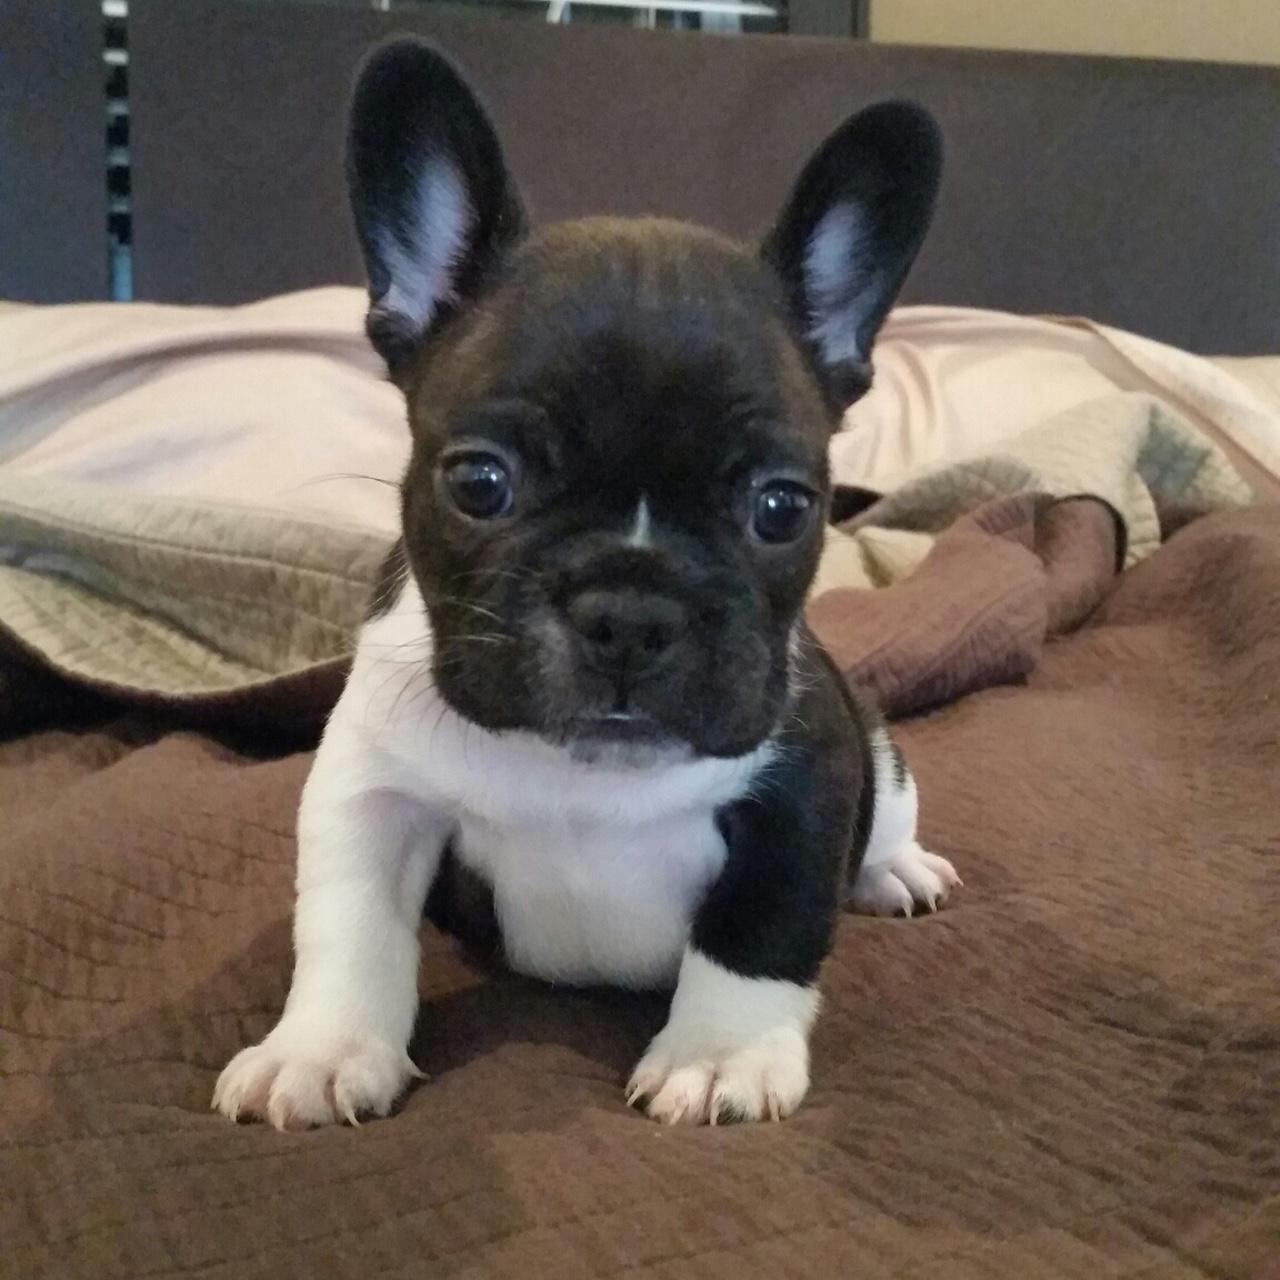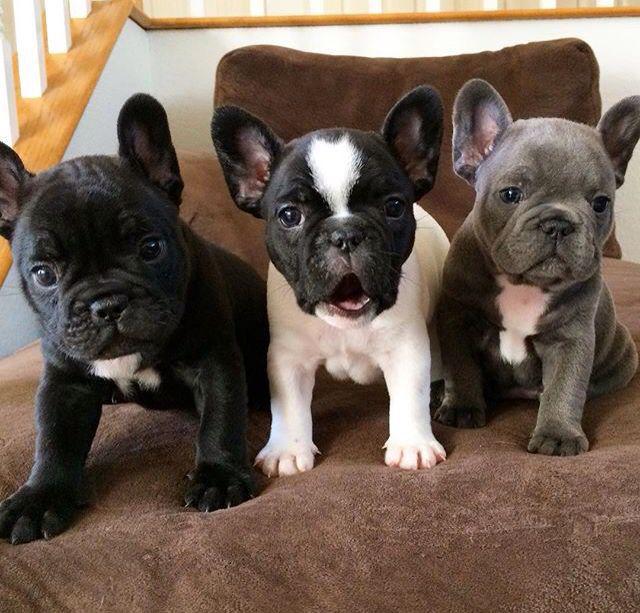The first image is the image on the left, the second image is the image on the right. Assess this claim about the two images: "The image on the left contains no more than one dog with its ears perked up.". Correct or not? Answer yes or no. Yes. The first image is the image on the left, the second image is the image on the right. Evaluate the accuracy of this statement regarding the images: "There are at most two dogs.". Is it true? Answer yes or no. No. 